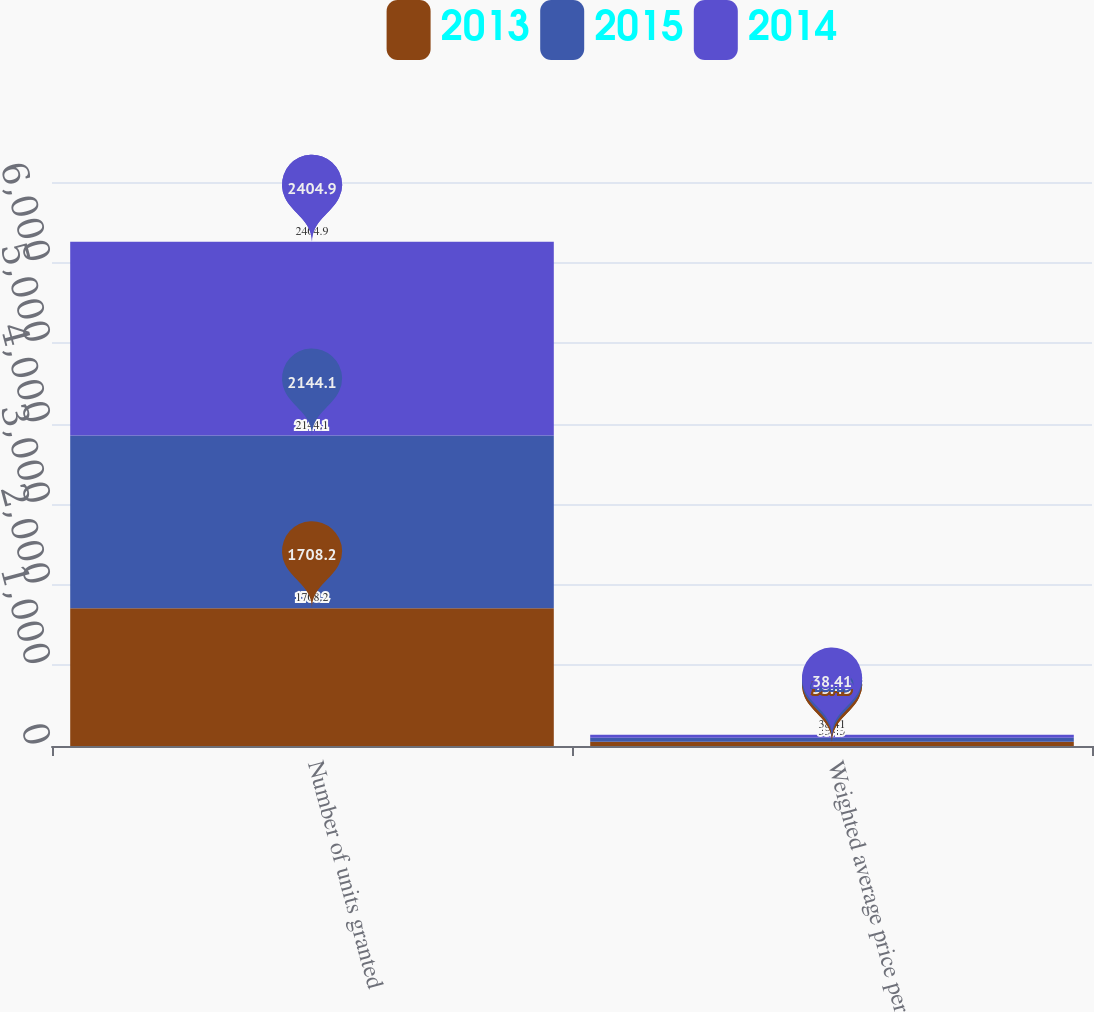Convert chart to OTSL. <chart><loc_0><loc_0><loc_500><loc_500><stacked_bar_chart><ecel><fcel>Number of units granted<fcel>Weighted average price per<nl><fcel>2013<fcel>1708.2<fcel>53.45<nl><fcel>2015<fcel>2144.1<fcel>48.49<nl><fcel>2014<fcel>2404.9<fcel>38.41<nl></chart> 